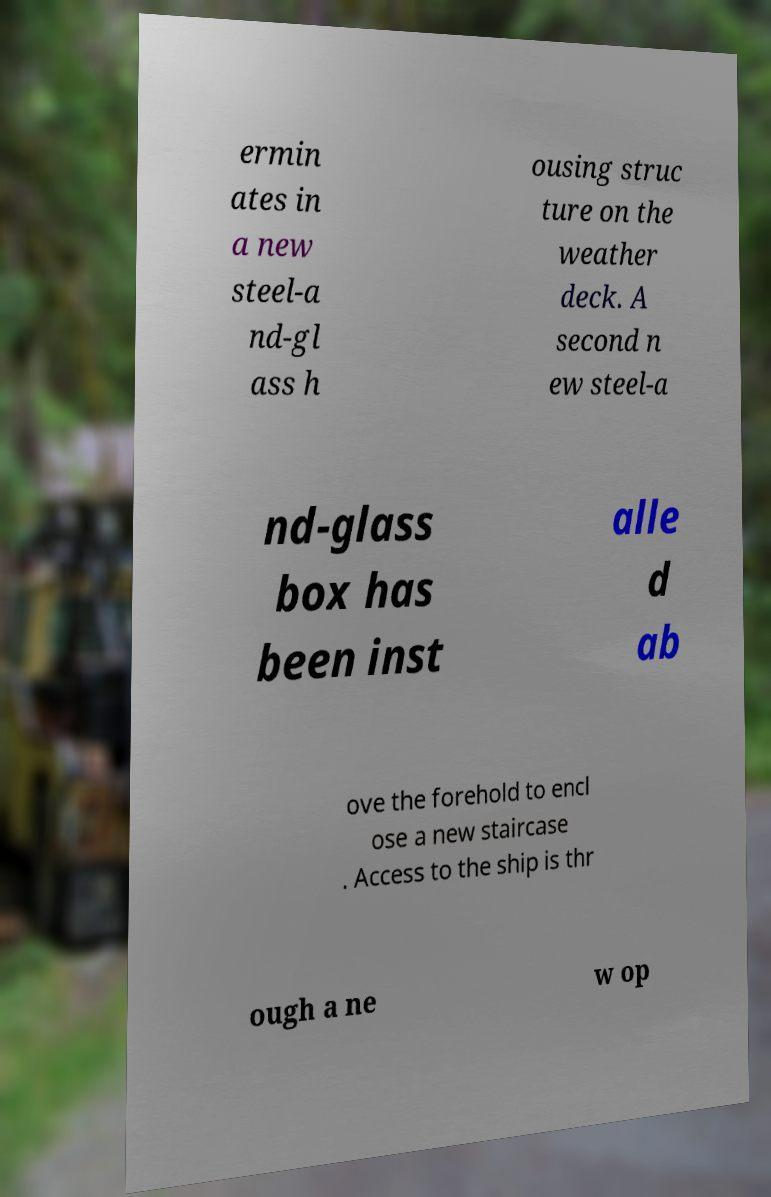Can you read and provide the text displayed in the image?This photo seems to have some interesting text. Can you extract and type it out for me? ermin ates in a new steel-a nd-gl ass h ousing struc ture on the weather deck. A second n ew steel-a nd-glass box has been inst alle d ab ove the forehold to encl ose a new staircase . Access to the ship is thr ough a ne w op 